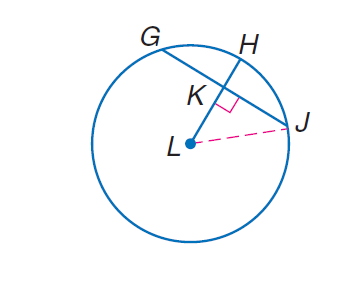Question: Circle L has a radius of 32 centimeters. L H \perp G J, and G J = 40 centimeters. Find L K.
Choices:
A. 20
B. \sqrt { 624 }
C. 40
D. 624
Answer with the letter. Answer: B 